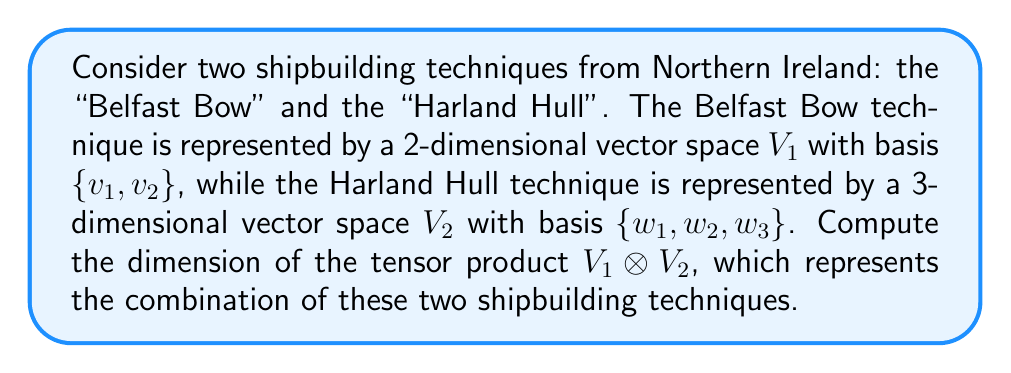What is the answer to this math problem? To compute the dimension of the tensor product of two vector spaces, we follow these steps:

1) Recall the formula for the dimension of a tensor product:
   $$\dim(V_1 \otimes V_2) = \dim(V_1) \cdot \dim(V_2)$$

2) Determine the dimensions of the individual vector spaces:
   $\dim(V_1) = 2$ (Belfast Bow technique)
   $\dim(V_2) = 3$ (Harland Hull technique)

3) Apply the formula:
   $$\dim(V_1 \otimes V_2) = 2 \cdot 3 = 6$$

This result indicates that the combined technique, represented by the tensor product, has 6 degrees of freedom or parameters, allowing for a richer set of design possibilities than either technique alone.
Answer: 6 